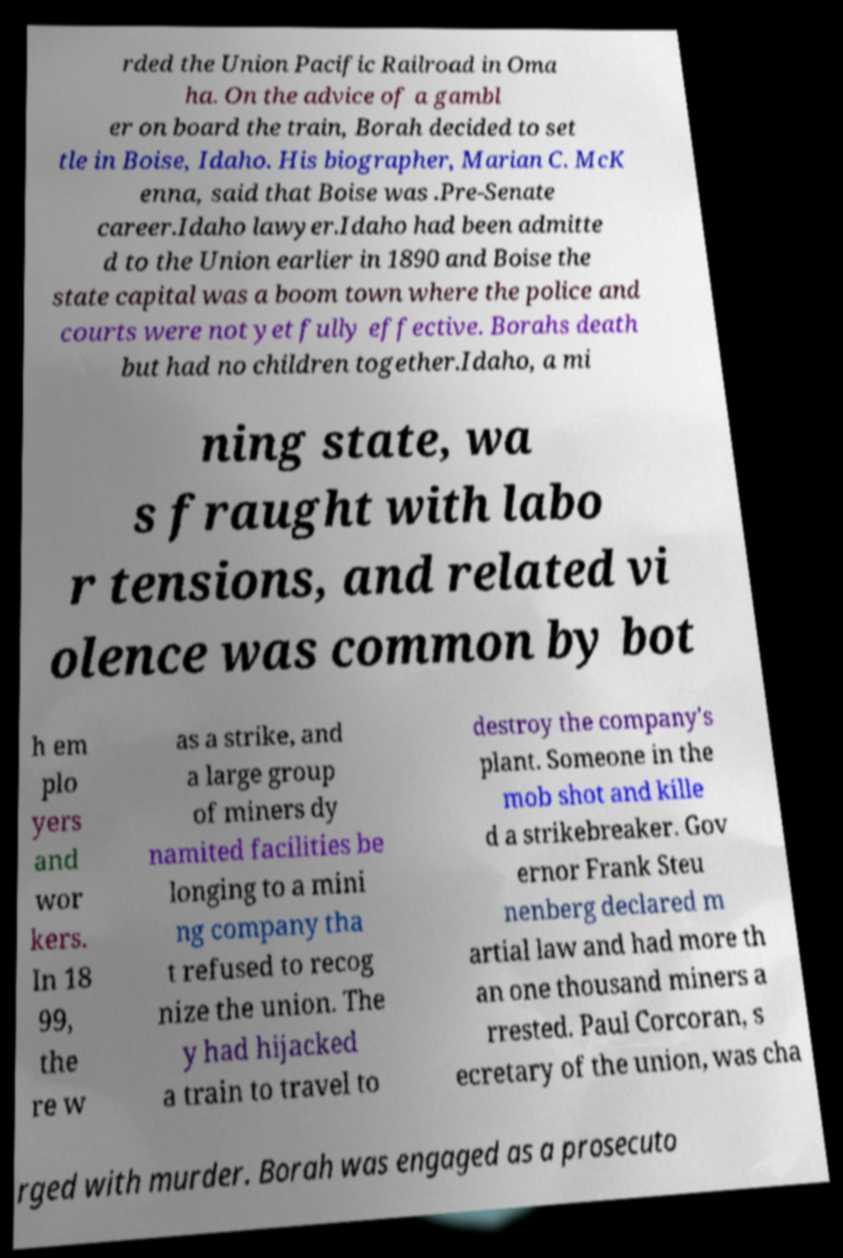Can you read and provide the text displayed in the image?This photo seems to have some interesting text. Can you extract and type it out for me? rded the Union Pacific Railroad in Oma ha. On the advice of a gambl er on board the train, Borah decided to set tle in Boise, Idaho. His biographer, Marian C. McK enna, said that Boise was .Pre-Senate career.Idaho lawyer.Idaho had been admitte d to the Union earlier in 1890 and Boise the state capital was a boom town where the police and courts were not yet fully effective. Borahs death but had no children together.Idaho, a mi ning state, wa s fraught with labo r tensions, and related vi olence was common by bot h em plo yers and wor kers. In 18 99, the re w as a strike, and a large group of miners dy namited facilities be longing to a mini ng company tha t refused to recog nize the union. The y had hijacked a train to travel to destroy the company's plant. Someone in the mob shot and kille d a strikebreaker. Gov ernor Frank Steu nenberg declared m artial law and had more th an one thousand miners a rrested. Paul Corcoran, s ecretary of the union, was cha rged with murder. Borah was engaged as a prosecuto 